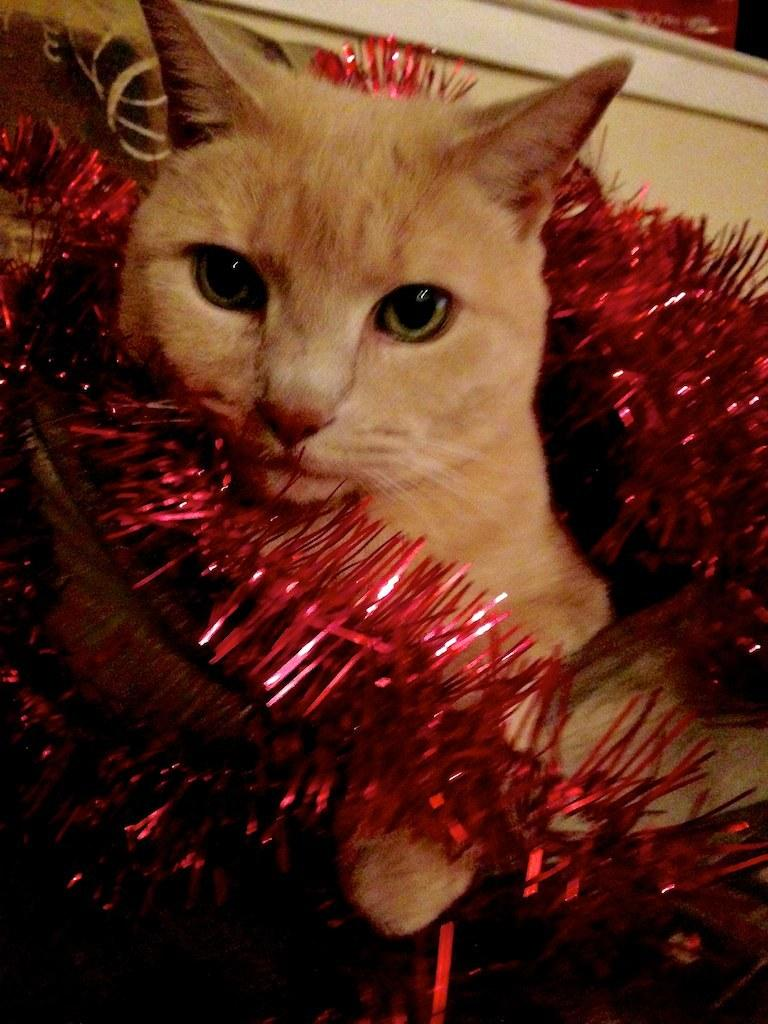What type of animal is in the image? There is a cat in the image. What color is the cat? The cat is brown in color. What is around the cat in the image? There is a decorative thread around the cat. What color is the decorative thread? The decorative thread is red in color. What can be seen in the background of the image? There is a cream-colored wall in the background of the image. What type of respect is the cat showing to the hammer in the image? There is no hammer present in the image, and the concept of respect is not applicable to cats in this context. 